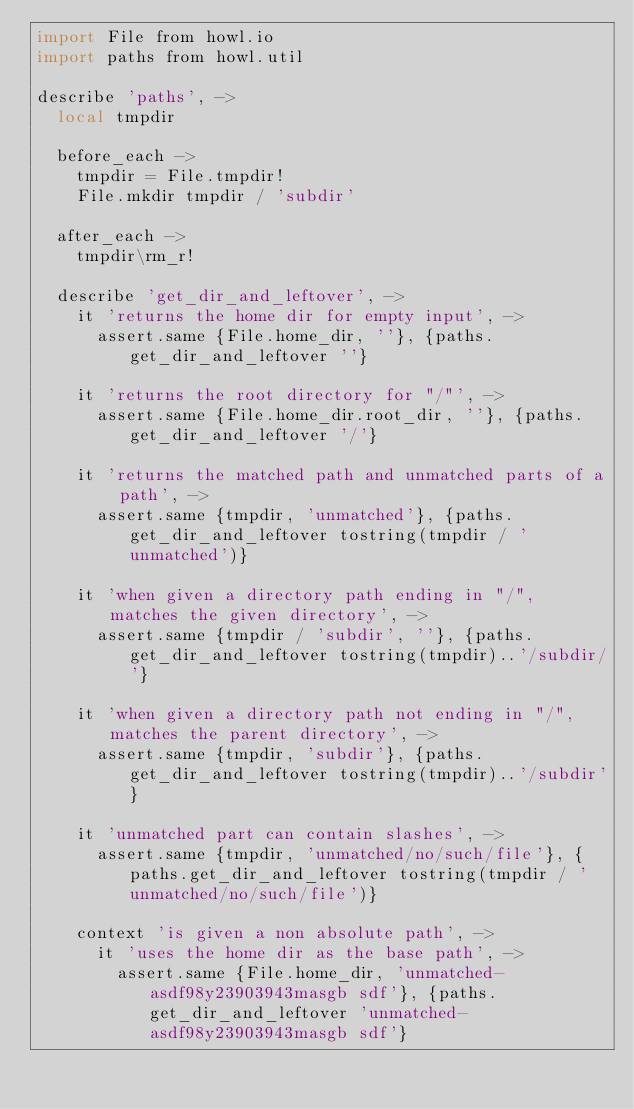Convert code to text. <code><loc_0><loc_0><loc_500><loc_500><_MoonScript_>import File from howl.io
import paths from howl.util

describe 'paths', ->
  local tmpdir

  before_each ->
    tmpdir = File.tmpdir!
    File.mkdir tmpdir / 'subdir'

  after_each ->
    tmpdir\rm_r!

  describe 'get_dir_and_leftover', ->
    it 'returns the home dir for empty input', ->
      assert.same {File.home_dir, ''}, {paths.get_dir_and_leftover ''}

    it 'returns the root directory for "/"', ->
      assert.same {File.home_dir.root_dir, ''}, {paths.get_dir_and_leftover '/'}

    it 'returns the matched path and unmatched parts of a path', ->
      assert.same {tmpdir, 'unmatched'}, {paths.get_dir_and_leftover tostring(tmpdir / 'unmatched')}

    it 'when given a directory path ending in "/", matches the given directory', ->
      assert.same {tmpdir / 'subdir', ''}, {paths.get_dir_and_leftover tostring(tmpdir)..'/subdir/'}

    it 'when given a directory path not ending in "/", matches the parent directory', ->
      assert.same {tmpdir, 'subdir'}, {paths.get_dir_and_leftover tostring(tmpdir)..'/subdir'}

    it 'unmatched part can contain slashes', ->
      assert.same {tmpdir, 'unmatched/no/such/file'}, {paths.get_dir_and_leftover tostring(tmpdir / 'unmatched/no/such/file')}

    context 'is given a non absolute path', ->
      it 'uses the home dir as the base path', ->
        assert.same {File.home_dir, 'unmatched-asdf98y23903943masgb sdf'}, {paths.get_dir_and_leftover 'unmatched-asdf98y23903943masgb sdf'}
</code> 